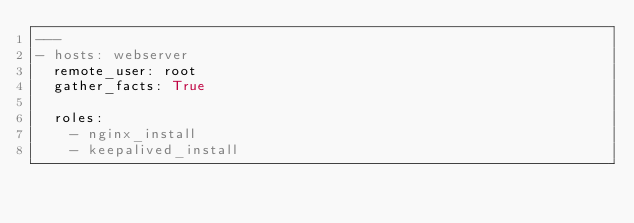Convert code to text. <code><loc_0><loc_0><loc_500><loc_500><_YAML_>---
- hosts: webserver
  remote_user: root
  gather_facts: True

  roles:
    - nginx_install
    - keepalived_install
</code> 